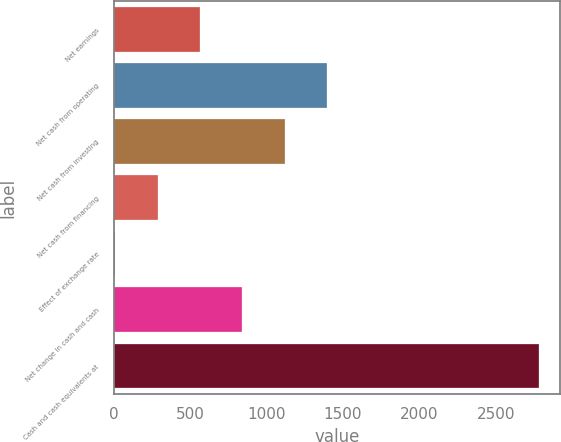Convert chart. <chart><loc_0><loc_0><loc_500><loc_500><bar_chart><fcel>Net earnings<fcel>Net cash from operating<fcel>Net cash from investing<fcel>Net cash from financing<fcel>Effect of exchange rate<fcel>Net change in cash and cash<fcel>Cash and cash equivalents at<nl><fcel>565.8<fcel>1396.5<fcel>1119.6<fcel>288.9<fcel>12<fcel>842.7<fcel>2781<nl></chart> 